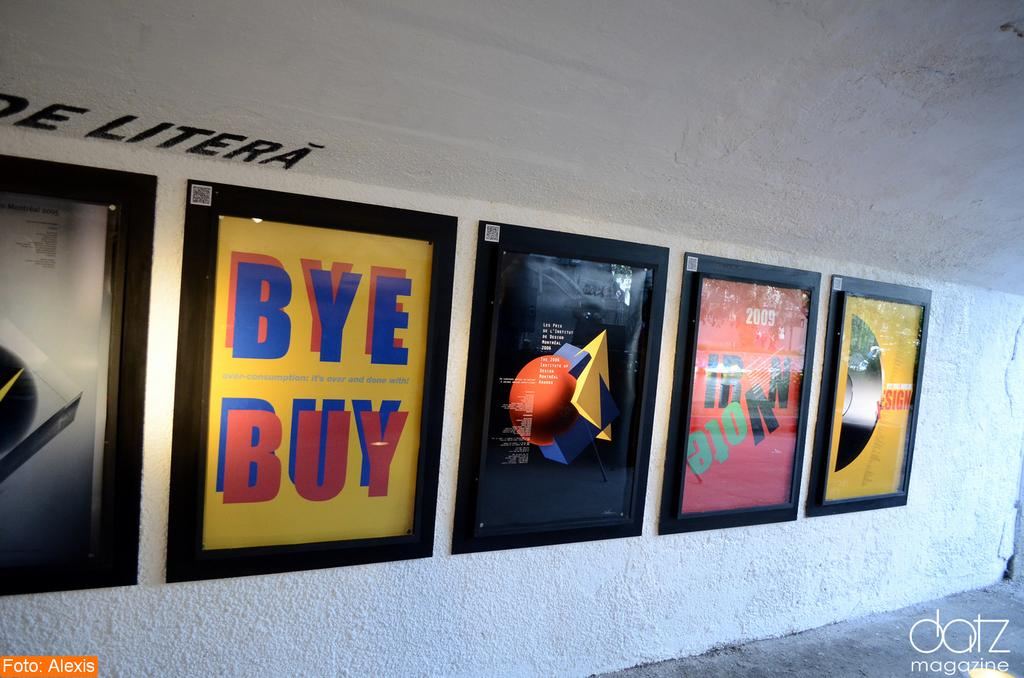Provide a one-sentence caption for the provided image. Several posters including a yellow one that says "Buy Bye" are framed on a white wall. 